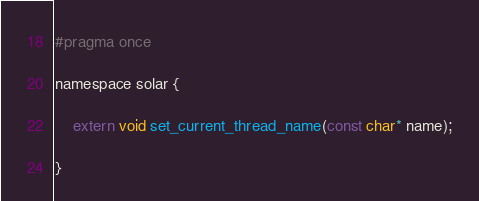<code> <loc_0><loc_0><loc_500><loc_500><_C_>#pragma once

namespace solar {

	extern void set_current_thread_name(const char* name);

}
</code> 